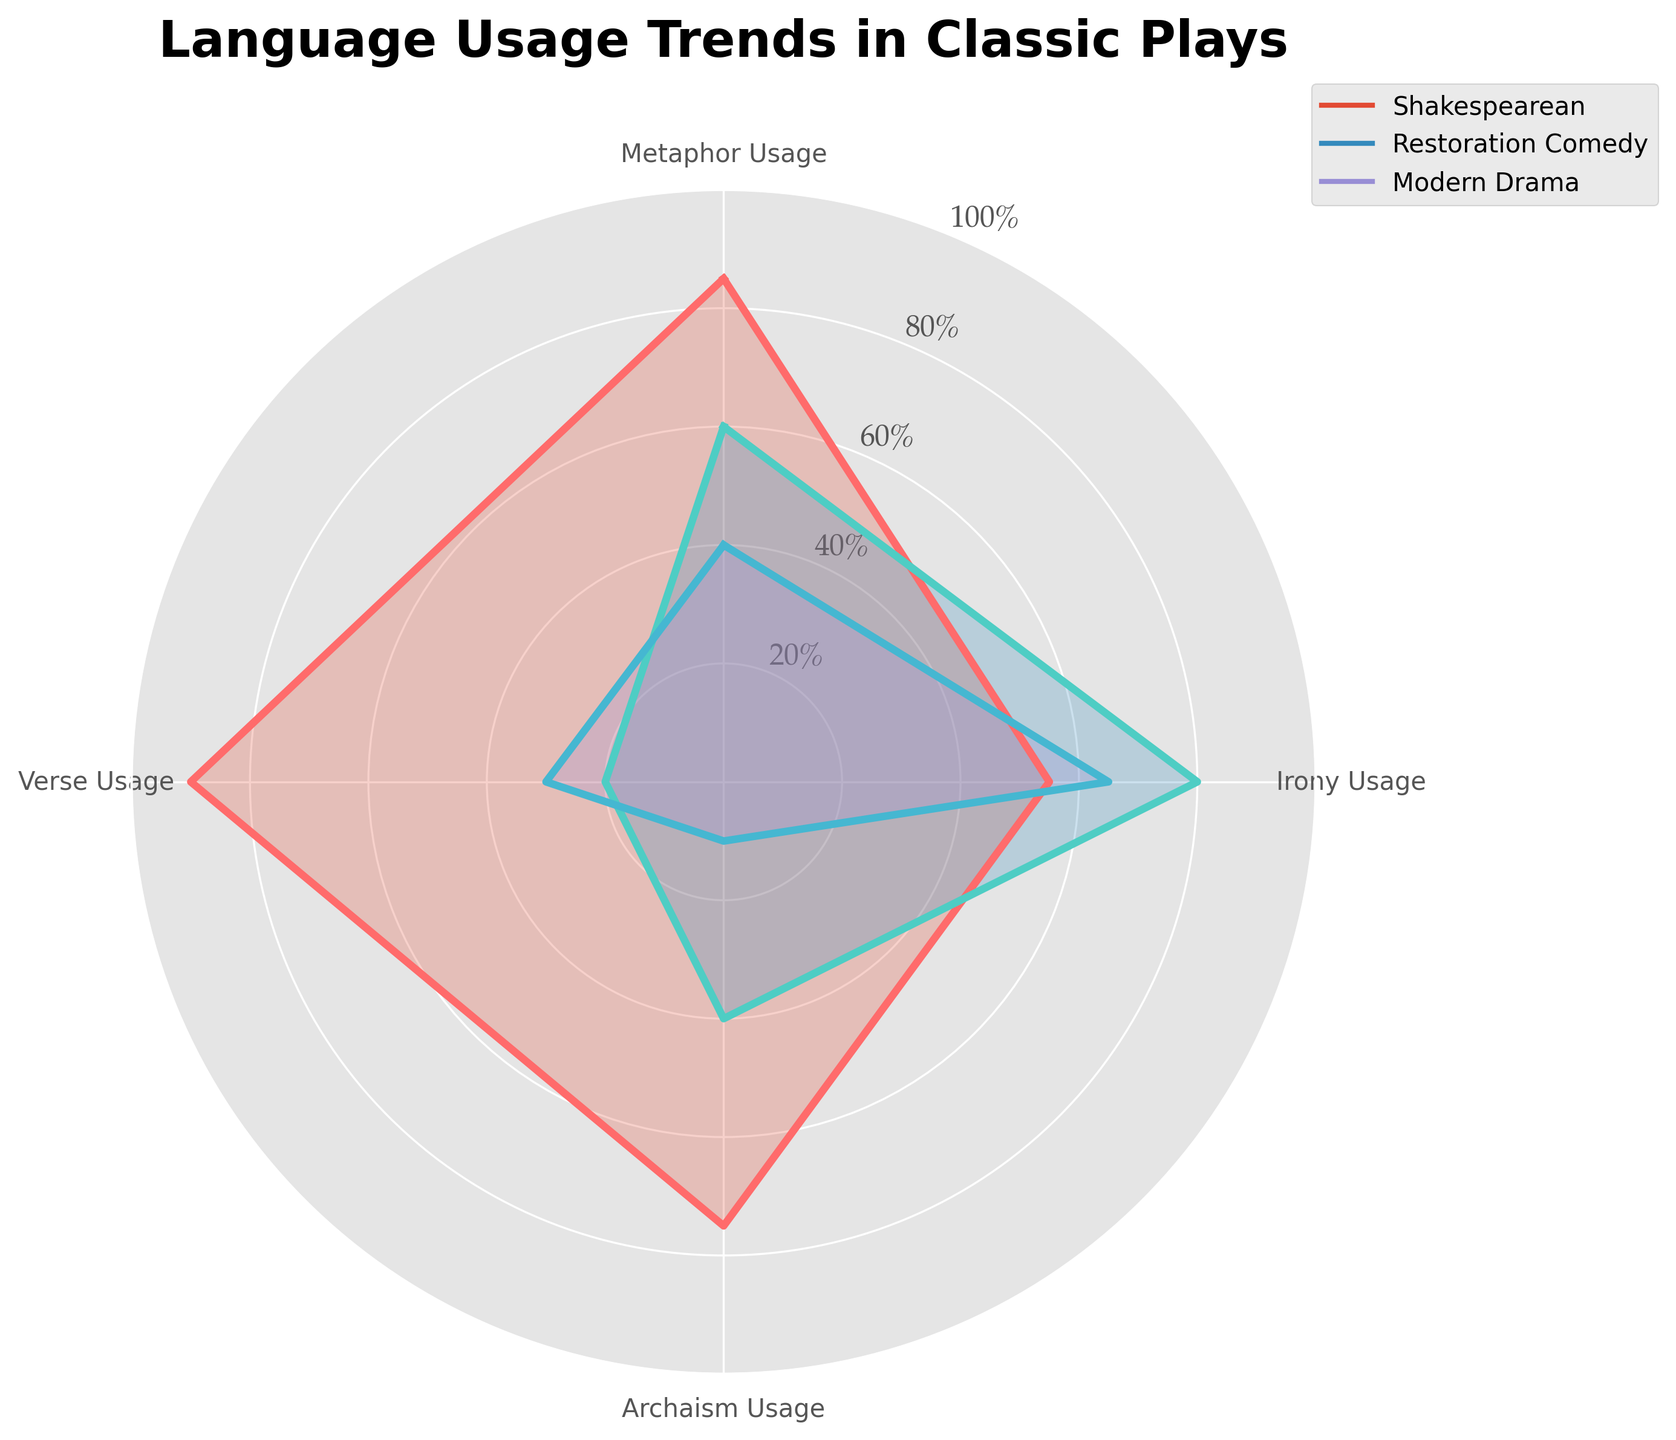What is the title of the radar chart? The title is found at the top of the radar chart. It summarizes what the chart represents.
Answer: Language Usage Trends in Classic Plays Which genre uses verse the most? By looking at the values plotted for each genre under the "Verse Usage" category, the highest point indicates the genre with the most usage.
Answer: Shakespearean What is the difference in metaphor usage between Shakespearean and Modern Drama? Check the values for metaphor usage for both genres and subtract the lower value from the higher value: 85 (Shakespearean) - 40 (Modern Drama) = 45.
Answer: 45 Which genre shows more irony usage: Restoration Comedy or Modern Drama? Compare the irony usage values for the two genres: 80 for Restoration Comedy and 65 for Modern Drama.
Answer: Restoration Comedy Rank the genres by their archaism usage from highest to lowest. Compare the values for archaism usage: Shakespearean (75), Restoration Comedy (40), Modern Drama (10). List them accordingly.
Answer: Shakespearean, Restoration Comedy, Modern Drama What is the average verse usage across all genres? Add the verse usage values for all genres and divide by the number of genres: (90 + 20 + 30) / 3 = 140 / 3 ≈ 46.67
Answer: 46.67 Which genre has the least variation in language element usage? Examine the ranges of values for each genre. The genre with the smallest difference between its highest and lowest values has the least variation.
Answer: Modern Drama Out of the four measures (Metaphor Usage, Irony Usage, Archaism Usage, Verse Usage), which one does Restoration Comedy score the lowest? Compare all four values for Restoration Comedy and identify the smallest one: Metaphor (60), Irony (80), Archaism (40), Verse (20).
Answer: Verse Usage By how much does Shakespearean drama exceed Restoration Comedy in archaism usage? Subtract the archaism usage value of Restoration Comedy (40) from that of Shakespearean (75): 75 - 40 = 35.
Answer: 35 In which category does Modern Drama's usage most closely compete with Restoration Comedy? Compare the differences in all categories: Metaphor (20), Irony (15), Archaism (30), Verse (10). The smallest difference indicates the closest competition.
Answer: Irony Usage 